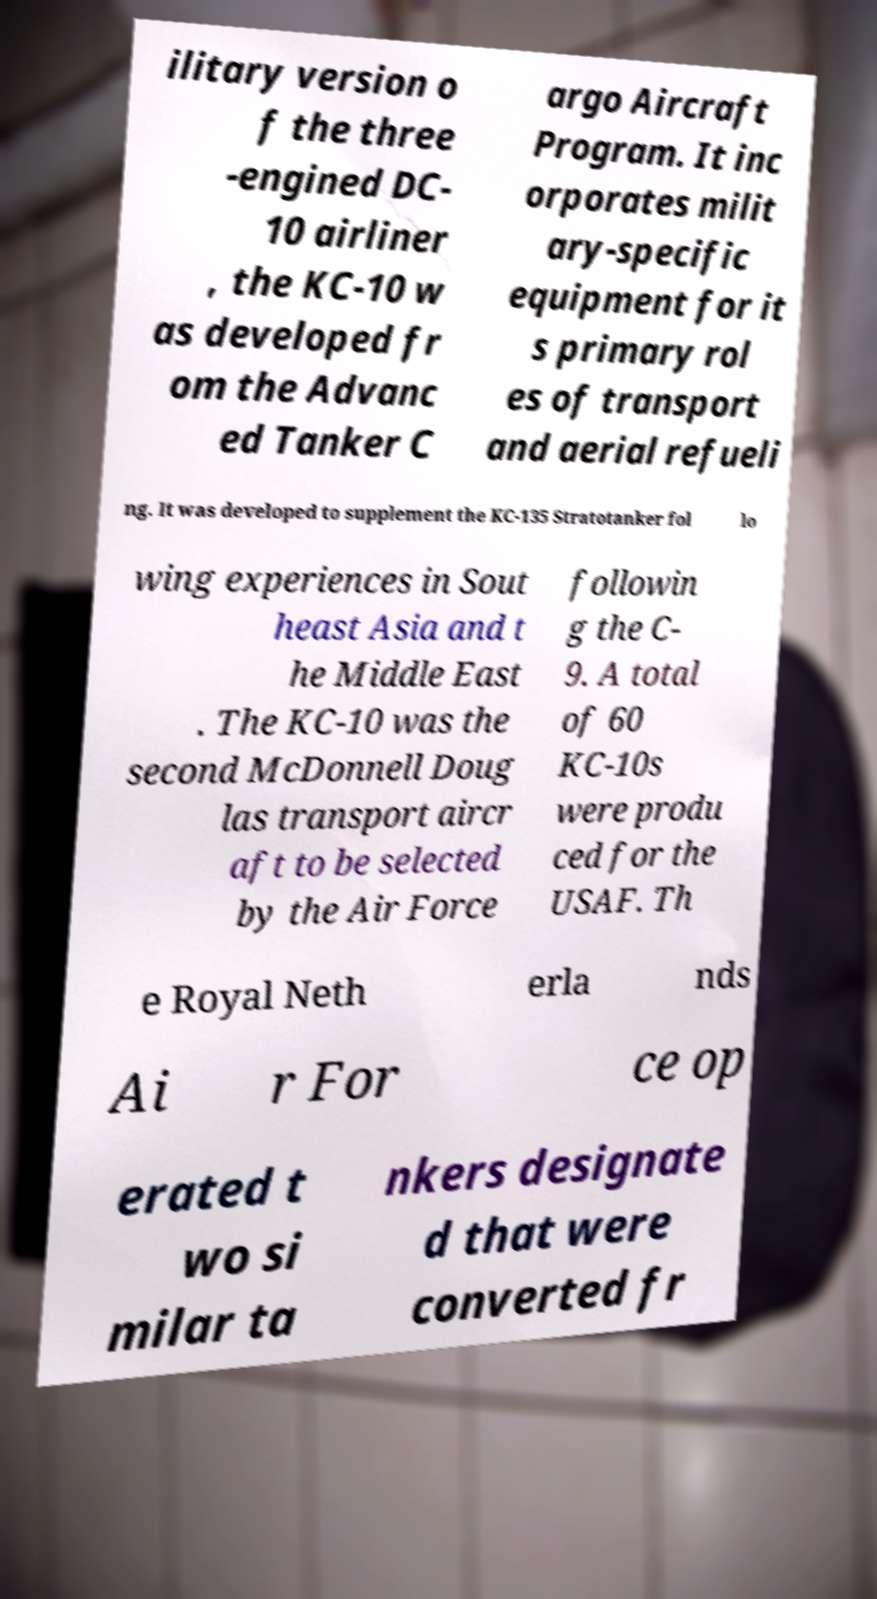Please identify and transcribe the text found in this image. ilitary version o f the three -engined DC- 10 airliner , the KC-10 w as developed fr om the Advanc ed Tanker C argo Aircraft Program. It inc orporates milit ary-specific equipment for it s primary rol es of transport and aerial refueli ng. It was developed to supplement the KC-135 Stratotanker fol lo wing experiences in Sout heast Asia and t he Middle East . The KC-10 was the second McDonnell Doug las transport aircr aft to be selected by the Air Force followin g the C- 9. A total of 60 KC-10s were produ ced for the USAF. Th e Royal Neth erla nds Ai r For ce op erated t wo si milar ta nkers designate d that were converted fr 